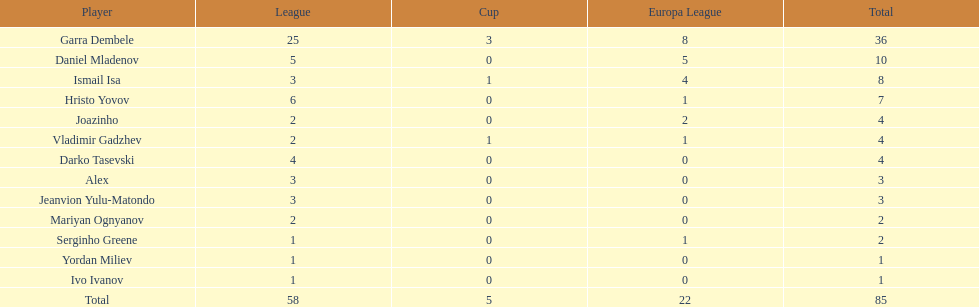Which sum is greater, the europa league total or the league total? League. 